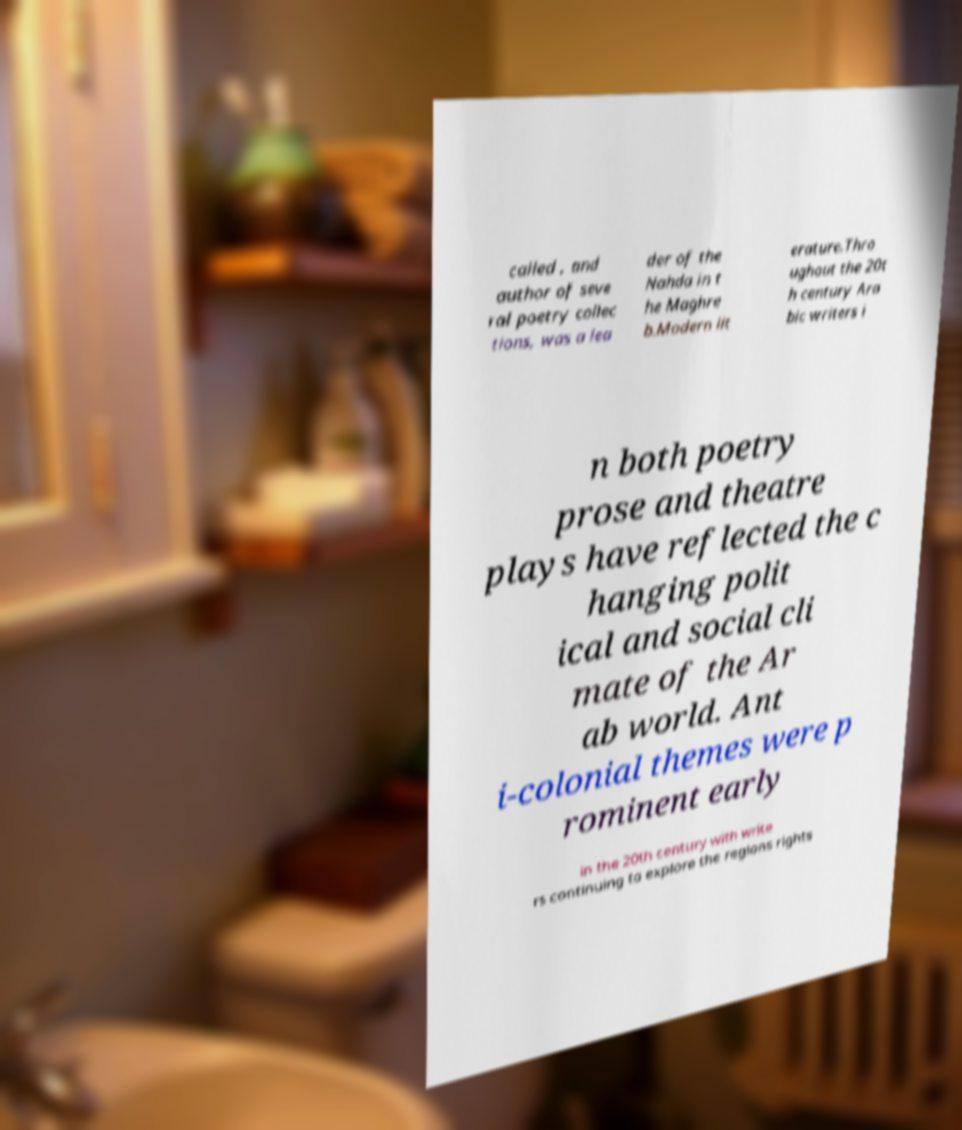I need the written content from this picture converted into text. Can you do that? called , and author of seve ral poetry collec tions, was a lea der of the Nahda in t he Maghre b.Modern lit erature.Thro ughout the 20t h century Ara bic writers i n both poetry prose and theatre plays have reflected the c hanging polit ical and social cli mate of the Ar ab world. Ant i-colonial themes were p rominent early in the 20th century with write rs continuing to explore the regions rights 